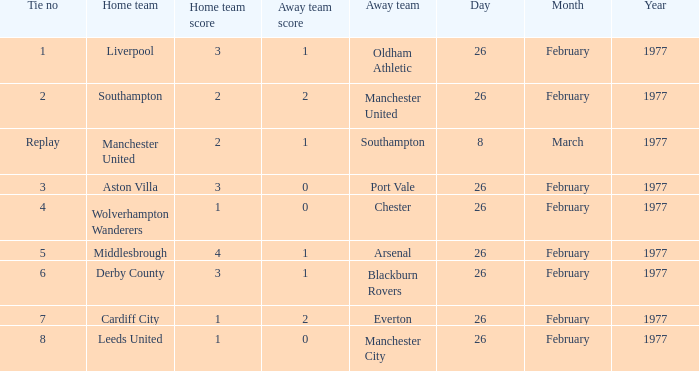What's the score when the Wolverhampton Wanderers played at home? 1–0. 